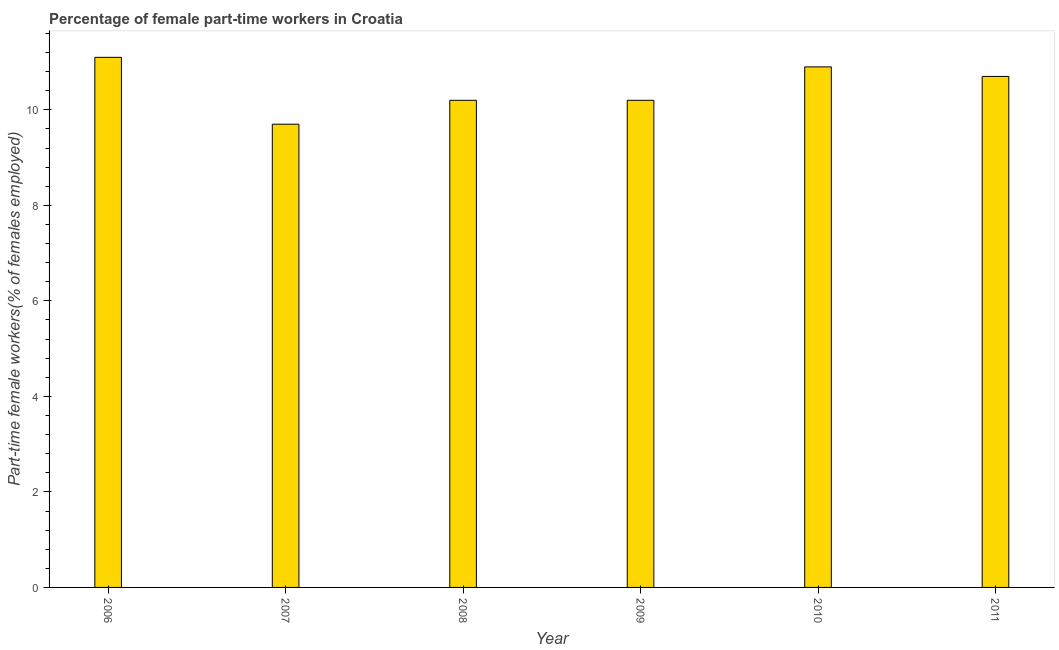Does the graph contain grids?
Ensure brevity in your answer.  No. What is the title of the graph?
Provide a short and direct response. Percentage of female part-time workers in Croatia. What is the label or title of the Y-axis?
Provide a succinct answer. Part-time female workers(% of females employed). What is the percentage of part-time female workers in 2009?
Offer a very short reply. 10.2. Across all years, what is the maximum percentage of part-time female workers?
Give a very brief answer. 11.1. Across all years, what is the minimum percentage of part-time female workers?
Your answer should be very brief. 9.7. What is the sum of the percentage of part-time female workers?
Keep it short and to the point. 62.8. What is the difference between the percentage of part-time female workers in 2009 and 2011?
Offer a terse response. -0.5. What is the average percentage of part-time female workers per year?
Your answer should be compact. 10.47. What is the median percentage of part-time female workers?
Ensure brevity in your answer.  10.45. In how many years, is the percentage of part-time female workers greater than 10 %?
Provide a short and direct response. 5. What is the ratio of the percentage of part-time female workers in 2008 to that in 2011?
Give a very brief answer. 0.95. What is the difference between the highest and the second highest percentage of part-time female workers?
Your answer should be very brief. 0.2. Is the sum of the percentage of part-time female workers in 2009 and 2011 greater than the maximum percentage of part-time female workers across all years?
Keep it short and to the point. Yes. In how many years, is the percentage of part-time female workers greater than the average percentage of part-time female workers taken over all years?
Your answer should be compact. 3. How many bars are there?
Ensure brevity in your answer.  6. Are the values on the major ticks of Y-axis written in scientific E-notation?
Ensure brevity in your answer.  No. What is the Part-time female workers(% of females employed) of 2006?
Your answer should be compact. 11.1. What is the Part-time female workers(% of females employed) of 2007?
Your answer should be very brief. 9.7. What is the Part-time female workers(% of females employed) of 2008?
Provide a succinct answer. 10.2. What is the Part-time female workers(% of females employed) of 2009?
Your response must be concise. 10.2. What is the Part-time female workers(% of females employed) in 2010?
Give a very brief answer. 10.9. What is the Part-time female workers(% of females employed) of 2011?
Make the answer very short. 10.7. What is the difference between the Part-time female workers(% of females employed) in 2006 and 2008?
Your answer should be very brief. 0.9. What is the difference between the Part-time female workers(% of females employed) in 2006 and 2010?
Ensure brevity in your answer.  0.2. What is the difference between the Part-time female workers(% of females employed) in 2006 and 2011?
Ensure brevity in your answer.  0.4. What is the difference between the Part-time female workers(% of females employed) in 2007 and 2009?
Your answer should be compact. -0.5. What is the difference between the Part-time female workers(% of females employed) in 2007 and 2011?
Make the answer very short. -1. What is the difference between the Part-time female workers(% of females employed) in 2008 and 2011?
Provide a short and direct response. -0.5. What is the ratio of the Part-time female workers(% of females employed) in 2006 to that in 2007?
Make the answer very short. 1.14. What is the ratio of the Part-time female workers(% of females employed) in 2006 to that in 2008?
Make the answer very short. 1.09. What is the ratio of the Part-time female workers(% of females employed) in 2006 to that in 2009?
Make the answer very short. 1.09. What is the ratio of the Part-time female workers(% of females employed) in 2006 to that in 2010?
Give a very brief answer. 1.02. What is the ratio of the Part-time female workers(% of females employed) in 2006 to that in 2011?
Give a very brief answer. 1.04. What is the ratio of the Part-time female workers(% of females employed) in 2007 to that in 2008?
Offer a terse response. 0.95. What is the ratio of the Part-time female workers(% of females employed) in 2007 to that in 2009?
Your answer should be very brief. 0.95. What is the ratio of the Part-time female workers(% of females employed) in 2007 to that in 2010?
Offer a terse response. 0.89. What is the ratio of the Part-time female workers(% of females employed) in 2007 to that in 2011?
Provide a succinct answer. 0.91. What is the ratio of the Part-time female workers(% of females employed) in 2008 to that in 2009?
Your response must be concise. 1. What is the ratio of the Part-time female workers(% of females employed) in 2008 to that in 2010?
Ensure brevity in your answer.  0.94. What is the ratio of the Part-time female workers(% of females employed) in 2008 to that in 2011?
Give a very brief answer. 0.95. What is the ratio of the Part-time female workers(% of females employed) in 2009 to that in 2010?
Provide a succinct answer. 0.94. What is the ratio of the Part-time female workers(% of females employed) in 2009 to that in 2011?
Offer a terse response. 0.95. 